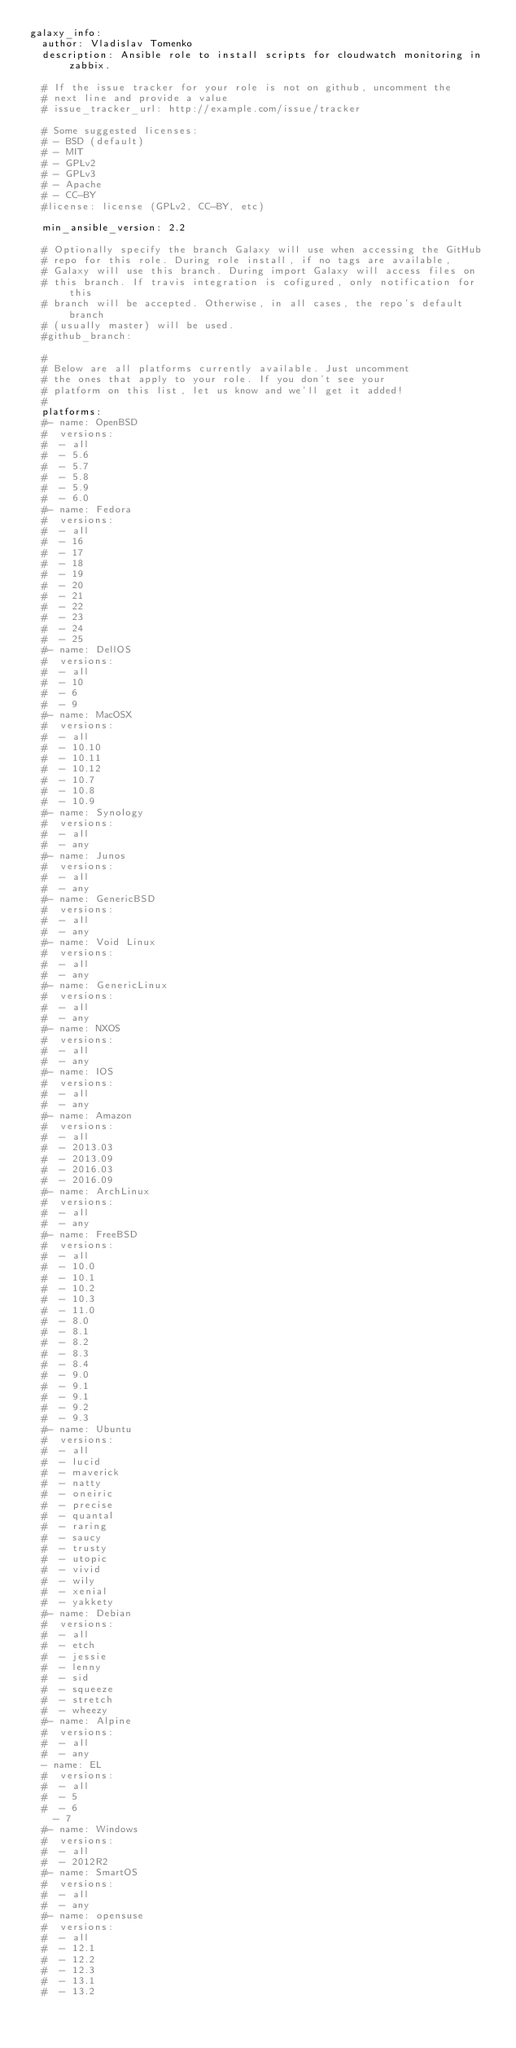<code> <loc_0><loc_0><loc_500><loc_500><_YAML_>galaxy_info:
  author: Vladislav Tomenko
  description: Ansible role to install scripts for cloudwatch monitoring in zabbix.

  # If the issue tracker for your role is not on github, uncomment the
  # next line and provide a value
  # issue_tracker_url: http://example.com/issue/tracker

  # Some suggested licenses:
  # - BSD (default)
  # - MIT
  # - GPLv2
  # - GPLv3
  # - Apache
  # - CC-BY
  #license: license (GPLv2, CC-BY, etc)

  min_ansible_version: 2.2

  # Optionally specify the branch Galaxy will use when accessing the GitHub
  # repo for this role. During role install, if no tags are available,
  # Galaxy will use this branch. During import Galaxy will access files on
  # this branch. If travis integration is cofigured, only notification for this
  # branch will be accepted. Otherwise, in all cases, the repo's default branch
  # (usually master) will be used.
  #github_branch:

  #
  # Below are all platforms currently available. Just uncomment
  # the ones that apply to your role. If you don't see your
  # platform on this list, let us know and we'll get it added!
  #
  platforms:
  #- name: OpenBSD
  #  versions:
  #  - all
  #  - 5.6
  #  - 5.7
  #  - 5.8
  #  - 5.9
  #  - 6.0
  #- name: Fedora
  #  versions:
  #  - all
  #  - 16
  #  - 17
  #  - 18
  #  - 19
  #  - 20
  #  - 21
  #  - 22
  #  - 23
  #  - 24
  #  - 25
  #- name: DellOS
  #  versions:
  #  - all
  #  - 10
  #  - 6
  #  - 9
  #- name: MacOSX
  #  versions:
  #  - all
  #  - 10.10
  #  - 10.11
  #  - 10.12
  #  - 10.7
  #  - 10.8
  #  - 10.9
  #- name: Synology
  #  versions:
  #  - all
  #  - any
  #- name: Junos
  #  versions:
  #  - all
  #  - any
  #- name: GenericBSD
  #  versions:
  #  - all
  #  - any
  #- name: Void Linux
  #  versions:
  #  - all
  #  - any
  #- name: GenericLinux
  #  versions:
  #  - all
  #  - any
  #- name: NXOS
  #  versions:
  #  - all
  #  - any
  #- name: IOS
  #  versions:
  #  - all
  #  - any
  #- name: Amazon
  #  versions:
  #  - all
  #  - 2013.03
  #  - 2013.09
  #  - 2016.03
  #  - 2016.09
  #- name: ArchLinux
  #  versions:
  #  - all
  #  - any
  #- name: FreeBSD
  #  versions:
  #  - all
  #  - 10.0
  #  - 10.1
  #  - 10.2
  #  - 10.3
  #  - 11.0
  #  - 8.0
  #  - 8.1
  #  - 8.2
  #  - 8.3
  #  - 8.4
  #  - 9.0
  #  - 9.1
  #  - 9.1
  #  - 9.2
  #  - 9.3
  #- name: Ubuntu
  #  versions:
  #  - all
  #  - lucid
  #  - maverick
  #  - natty
  #  - oneiric
  #  - precise
  #  - quantal
  #  - raring
  #  - saucy
  #  - trusty
  #  - utopic
  #  - vivid
  #  - wily
  #  - xenial
  #  - yakkety
  #- name: Debian
  #  versions:
  #  - all
  #  - etch
  #  - jessie
  #  - lenny
  #  - sid
  #  - squeeze
  #  - stretch
  #  - wheezy
  #- name: Alpine
  #  versions:
  #  - all
  #  - any
  - name: EL
  #  versions:
  #  - all
  #  - 5
  #  - 6
    - 7
  #- name: Windows
  #  versions:
  #  - all
  #  - 2012R2
  #- name: SmartOS
  #  versions:
  #  - all
  #  - any
  #- name: opensuse
  #  versions:
  #  - all
  #  - 12.1
  #  - 12.2
  #  - 12.3
  #  - 13.1
  #  - 13.2</code> 